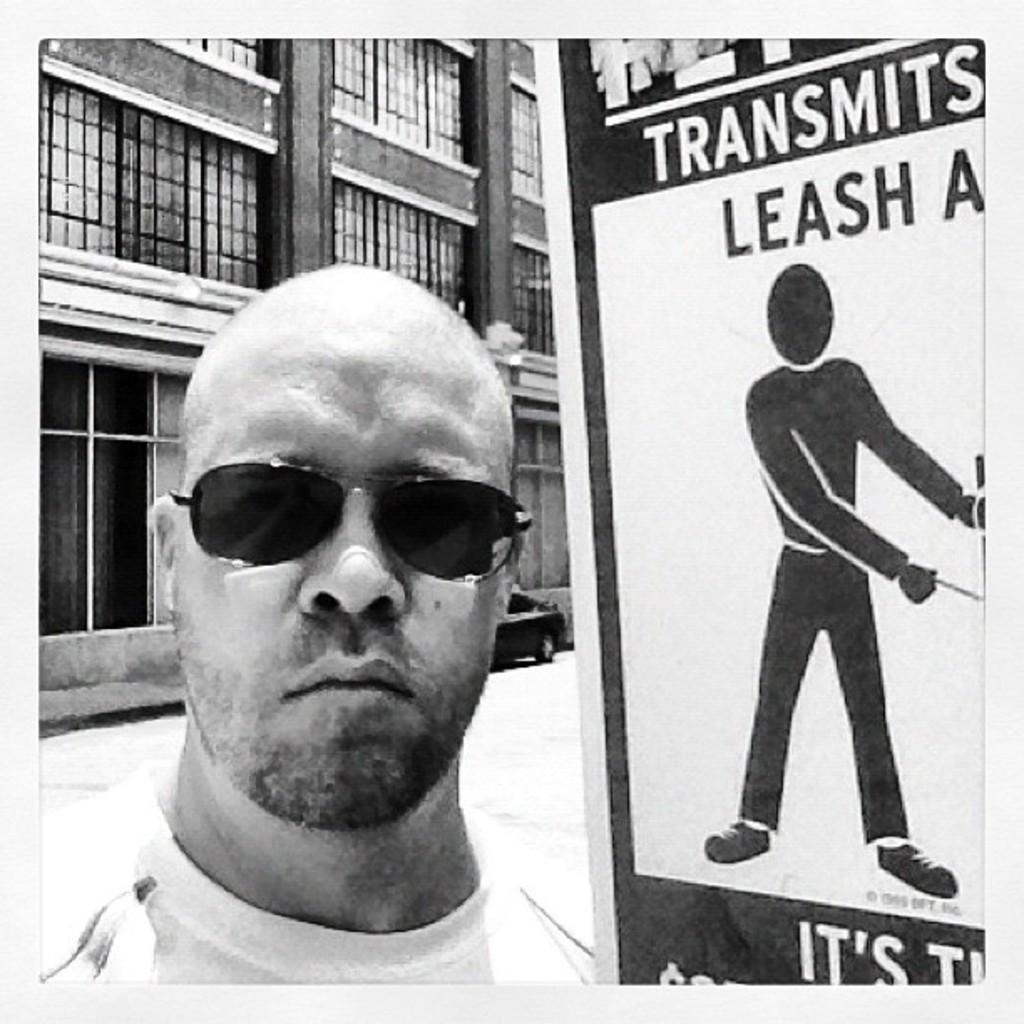Who is the main subject in the image? There is a man in the image. What is the man wearing that is noticeable? The man is wearing black sunglasses. What is the man doing in the image? The man is looking into the camera. What can be seen beside the man in the image? There is a white poster beside the man. What is visible in the background of the image? There is a building with a glass window in the background of the image. What type of note is the man holding in the image? There is no note visible in the image; the man is wearing sunglasses and looking into the camera. What is the man eating for lunch in the image? There is no lunch present in the image; the man is wearing sunglasses and looking into the camera. 